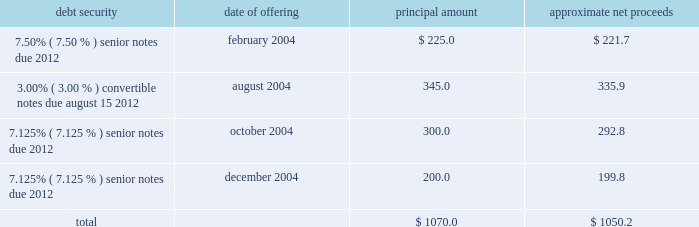Proceeds from the sale of equity securities .
From time to time , we raise funds through public offerings of our equity securities .
In addition , we receive proceeds from sales of our equity securities pursuant to our stock option and stock purchase plans .
For the year ended december 31 , 2004 , we received approximately $ 40.6 million in proceeds from sales of shares of our class a common stock and the common stock of atc mexico pursuant to our stock option and stock purchase plans .
Financing activities during the year ended december 31 , 2004 , we took several actions to increase our financial flexibility and reduce our interest costs .
New credit facility .
In may 2004 , we refinanced our previous credit facility with a new $ 1.1 billion senior secured credit facility .
At closing , we received $ 685.5 million of net proceeds from the borrowings under the new facility , after deducting related expenses and fees , approximately $ 670.0 million of which we used to repay principal and interest under the previous credit facility .
We used the remaining net proceeds of $ 15.5 million for general corporate purposes , including the repurchase of other outstanding debt securities .
The new credit facility consists of the following : 2022 $ 400.0 million in undrawn revolving loan commitments , against which approximately $ 19.3 million of undrawn letters of credit were outstanding at december 31 , 2004 , maturing on february 28 , 2011 ; 2022 a $ 300.0 million term loan a , which is fully drawn , maturing on february 28 , 2011 ; and 2022 a $ 398.0 million term loan b , which is fully drawn , maturing on august 31 , 2011 .
The new credit facility extends the previous credit facility maturity dates from 2007 to 2011 for a majority of the borrowings outstanding , subject to earlier maturity upon the occurrence of certain events described below , and allows us to use credit facility borrowings and internally generated funds to repurchase other indebtedness without additional lender approval .
The new credit facility is guaranteed by us and is secured by a pledge of substantially all of our assets .
The maturity date for term loan a and any outstanding revolving loans will be accelerated to august 15 , 2008 , and the maturity date for term loan b will be accelerated to october 31 , 2008 , if ( 1 ) on or prior to august 1 , 2008 , our 93 20448% ( 20448 % ) senior notes have not been ( a ) refinanced with parent company indebtedness having a maturity date of february 28 , 2012 or later or with loans under the new credit facility , or ( b ) repaid , prepaid , redeemed , repurchased or otherwise retired , and ( 2 ) our consolidated leverage ratio ( total parent company debt to annualized operating cash flow ) at june 30 , 2008 is greater than 4.50 to 1.00 .
If this were to occur , the payments due in 2008 for term loan a and term loan b would be $ 225.0 million and $ 386.0 million , respectively .
Note offerings .
During 2004 , we raised approximately $ 1.1 billion in net proceeds from the sale of debt securities through institutional private placements as follows ( in millions ) : debt security date of offering principal amount approximate net proceeds .
2022 7.50% ( 7.50 % ) senior notes offering .
In february 2004 , we sold $ 225.0 million principal amount of our 7.50% ( 7.50 % ) senior notes due 2012 through an institutional private placement .
The 7.50% ( 7.50 % ) senior notes mature on may 1 , 2012 , and interest is payable semiannually in arrears on may 1 and november 1 of each year. .
What is the annual interest expense related to the 3.00% ( 3.00 % ) convertible notes , in millions? 
Computations: (345.0 * 3.00%)
Answer: 10.35. 